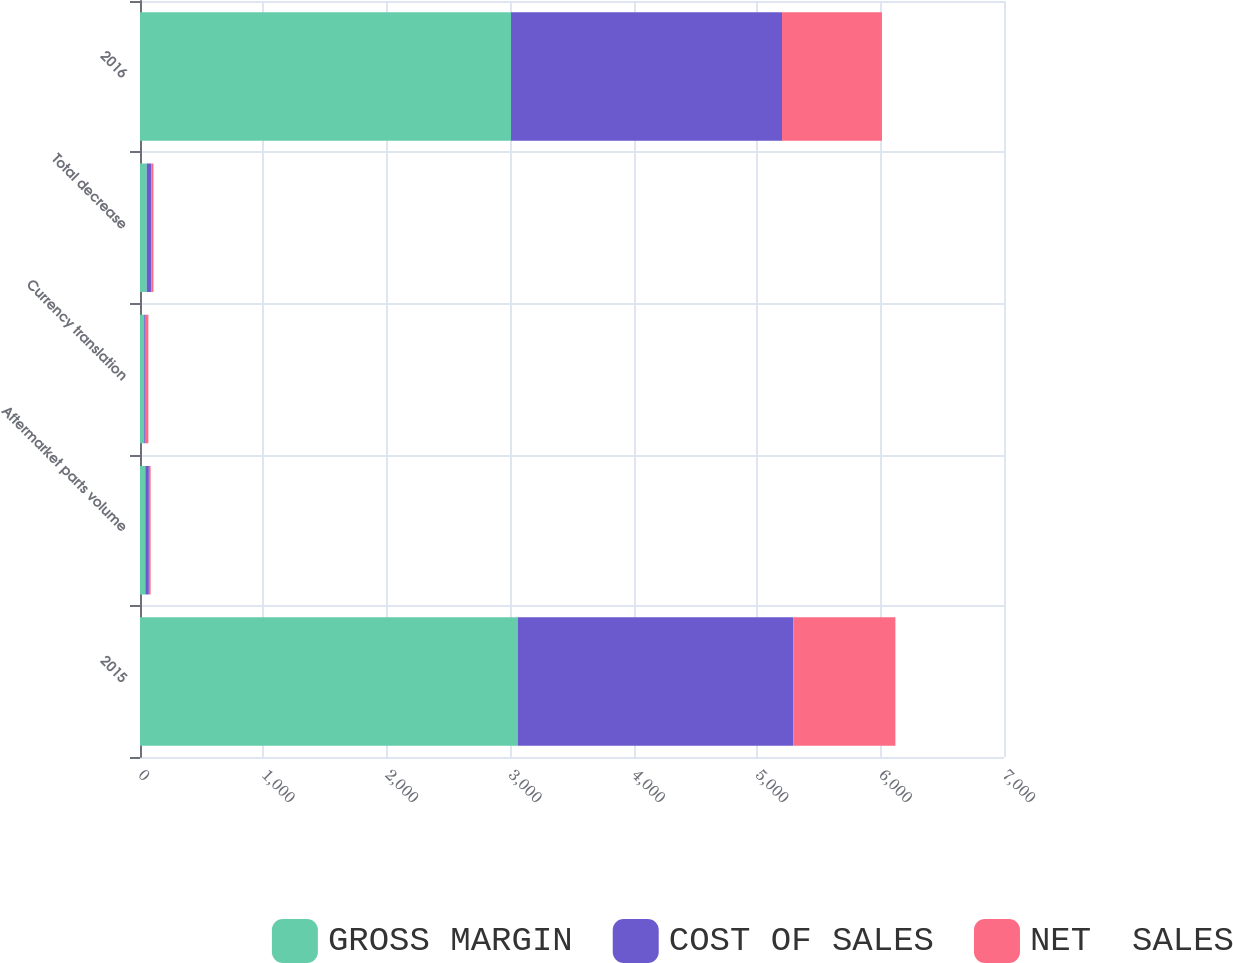<chart> <loc_0><loc_0><loc_500><loc_500><stacked_bar_chart><ecel><fcel>2015<fcel>Aftermarket parts volume<fcel>Currency translation<fcel>Total decrease<fcel>2016<nl><fcel>GROSS MARGIN<fcel>3060.1<fcel>43<fcel>33.9<fcel>54.4<fcel>3005.7<nl><fcel>COST OF SALES<fcel>2232.4<fcel>28.9<fcel>12.2<fcel>36.7<fcel>2195.7<nl><fcel>NET  SALES<fcel>827.7<fcel>14.1<fcel>21.7<fcel>17.7<fcel>810<nl></chart> 